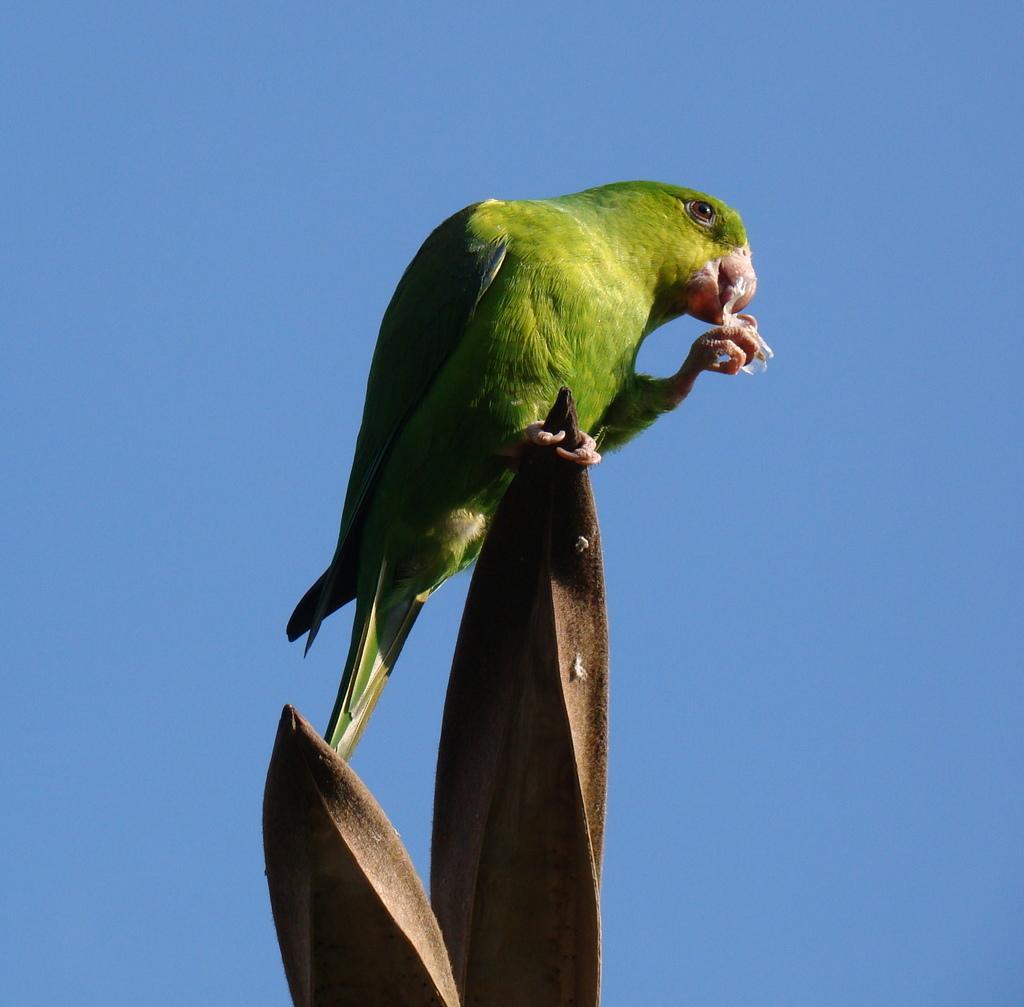Could you give a brief overview of what you see in this image? In this picture we can see a bird on an object. Behind the bird there is the sky. 